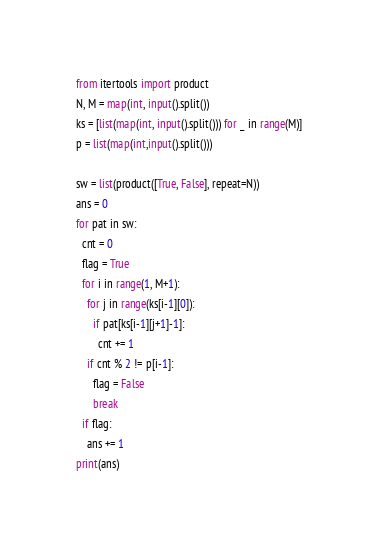<code> <loc_0><loc_0><loc_500><loc_500><_Python_>from itertools import product
N, M = map(int, input().split())
ks = [list(map(int, input().split())) for _ in range(M)]
p = list(map(int,input().split()))

sw = list(product([True, False], repeat=N))
ans = 0
for pat in sw:
  cnt = 0
  flag = True
  for i in range(1, M+1):
    for j in range(ks[i-1][0]):
      if pat[ks[i-1][j+1]-1]:
        cnt += 1
    if cnt % 2 != p[i-1]:
      flag = False
      break
  if flag:
    ans += 1
print(ans)</code> 